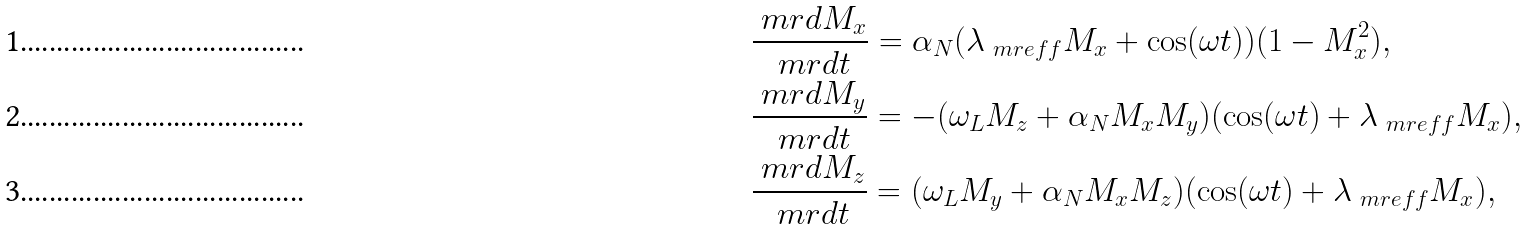Convert formula to latex. <formula><loc_0><loc_0><loc_500><loc_500>& \frac { \ m r { d } M _ { x } } { \ m r { d } t } = \alpha _ { N } ( \lambda _ { \ m r { e f f } } M _ { x } + \cos ( \omega t ) ) ( 1 - M _ { x } ^ { 2 } ) , \\ & \frac { \ m r { d } M _ { y } } { \ m r { d } t } = - ( \omega _ { L } M _ { z } + \alpha _ { N } M _ { x } M _ { y } ) ( \cos ( \omega t ) + \lambda _ { \ m r { e f f } } M _ { x } ) , \\ & \frac { \ m r { d } M _ { z } } { \ m r { d } t } = ( \omega _ { L } M _ { y } + \alpha _ { N } M _ { x } M _ { z } ) ( \cos ( \omega t ) + \lambda _ { \ m r { e f f } } M _ { x } ) ,</formula> 